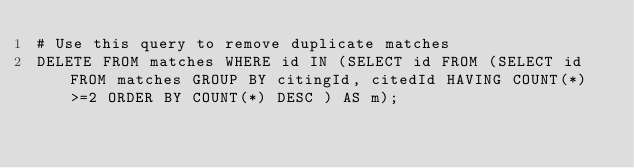Convert code to text. <code><loc_0><loc_0><loc_500><loc_500><_SQL_># Use this query to remove duplicate matches
DELETE FROM matches WHERE id IN (SELECT id FROM (SELECT id FROM matches GROUP BY citingId, citedId HAVING COUNT(*)>=2 ORDER BY COUNT(*) DESC ) AS m);</code> 